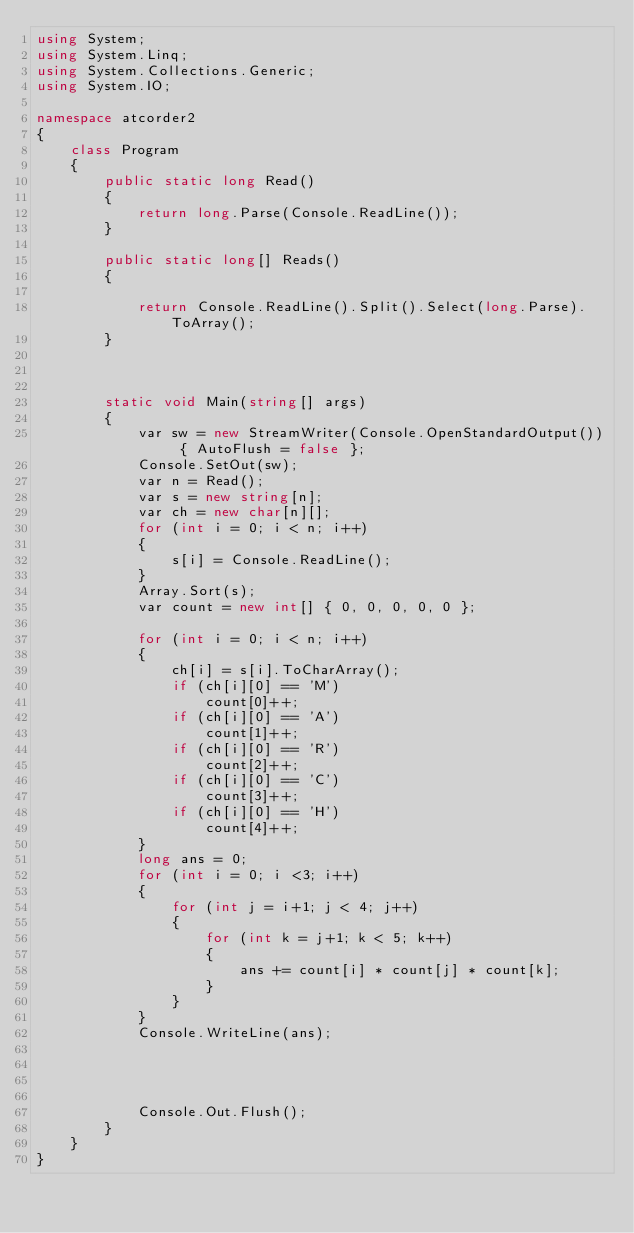<code> <loc_0><loc_0><loc_500><loc_500><_C#_>using System;
using System.Linq;
using System.Collections.Generic;
using System.IO;

namespace atcorder2
{
    class Program
    {
        public static long Read()
        {
            return long.Parse(Console.ReadLine());
        }

        public static long[] Reads()
        {

            return Console.ReadLine().Split().Select(long.Parse).ToArray();
        }

        

        static void Main(string[] args)
        {
            var sw = new StreamWriter(Console.OpenStandardOutput()) { AutoFlush = false };
            Console.SetOut(sw);
            var n = Read();
            var s = new string[n];
            var ch = new char[n][];
            for (int i = 0; i < n; i++)
            {
                s[i] = Console.ReadLine();
            }
            Array.Sort(s);
            var count = new int[] { 0, 0, 0, 0, 0 };

            for (int i = 0; i < n; i++)
            {
                ch[i] = s[i].ToCharArray();
                if (ch[i][0] == 'M')
                    count[0]++;
                if (ch[i][0] == 'A')
                    count[1]++;
                if (ch[i][0] == 'R')
                    count[2]++;
                if (ch[i][0] == 'C')
                    count[3]++;
                if (ch[i][0] == 'H')
                    count[4]++;
            }
            long ans = 0;
            for (int i = 0; i <3; i++)
            {
                for (int j = i+1; j < 4; j++)
                {
                    for (int k = j+1; k < 5; k++)
                    {
                        ans += count[i] * count[j] * count[k];
                    }
                }
            }
            Console.WriteLine(ans);
           
          


            Console.Out.Flush();
        }
    }
}</code> 